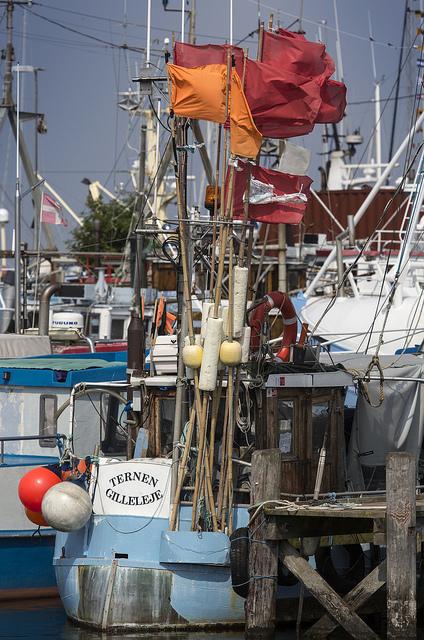What colors are the balloons?
Write a very short answer. Red and white. Are all the flags the same color?
Give a very brief answer. No. How many balloons are there?
Write a very short answer. 0. Where is this?
Concise answer only. Marina. 